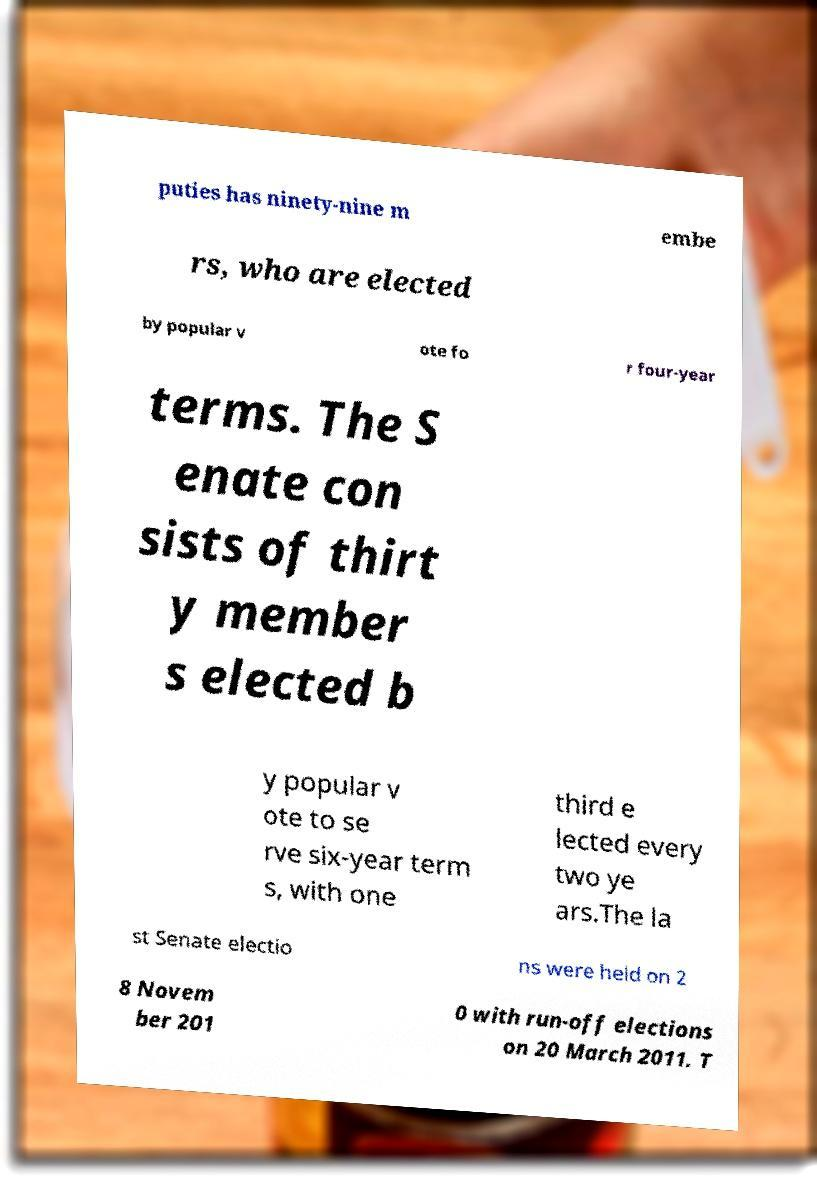I need the written content from this picture converted into text. Can you do that? puties has ninety-nine m embe rs, who are elected by popular v ote fo r four-year terms. The S enate con sists of thirt y member s elected b y popular v ote to se rve six-year term s, with one third e lected every two ye ars.The la st Senate electio ns were held on 2 8 Novem ber 201 0 with run-off elections on 20 March 2011. T 